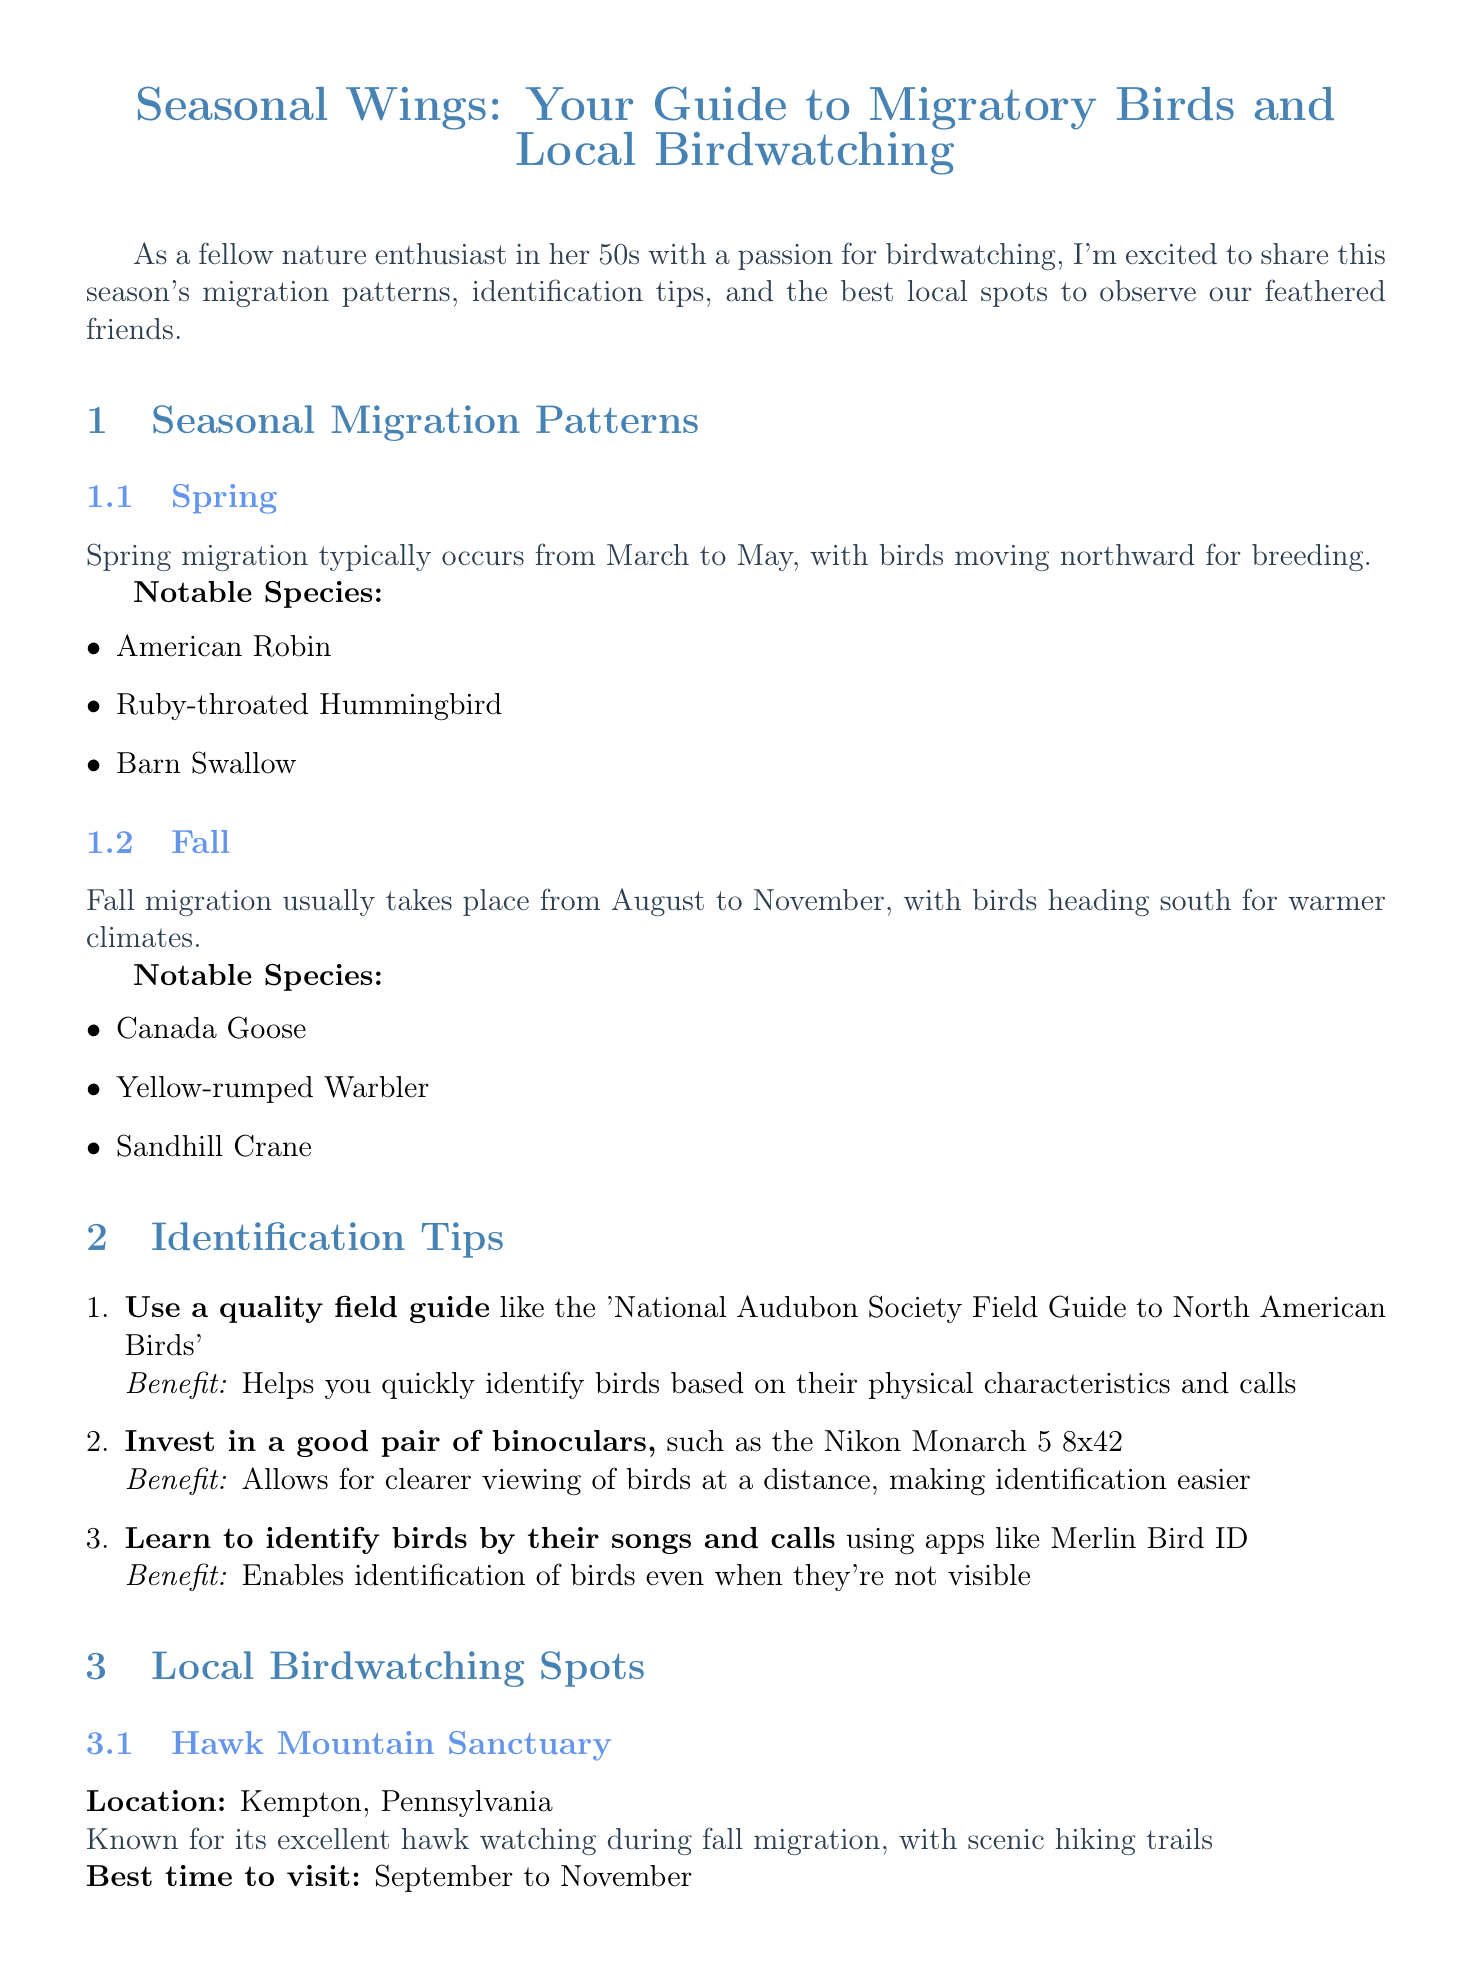What time does spring migration occur? Spring migration typically occurs from March to May, indicating the timeframe for bird movement northward.
Answer: March to May Which species can be seen in the fall? The notable species listed for fall migration include specific birds that migrate south, highlighting good observation opportunities.
Answer: Canada Goose What is the best time to visit Hawk Mountain Sanctuary? The document specifies September to November as the ideal visiting window for observing hawks during their migration.
Answer: September to November What type of birds do you attract by planting Black-eyed Susan? This flower attracts a specific type of bird, which indicates the importance of local flora in attracting wildlife.
Answer: Hummingbirds How can you combine hiking with birdwatching? The newsletter offers practical tips that allow individuals to engage in both activities simultaneously, enhancing their outdoor experiences.
Answer: Choose trails with diverse habitats 